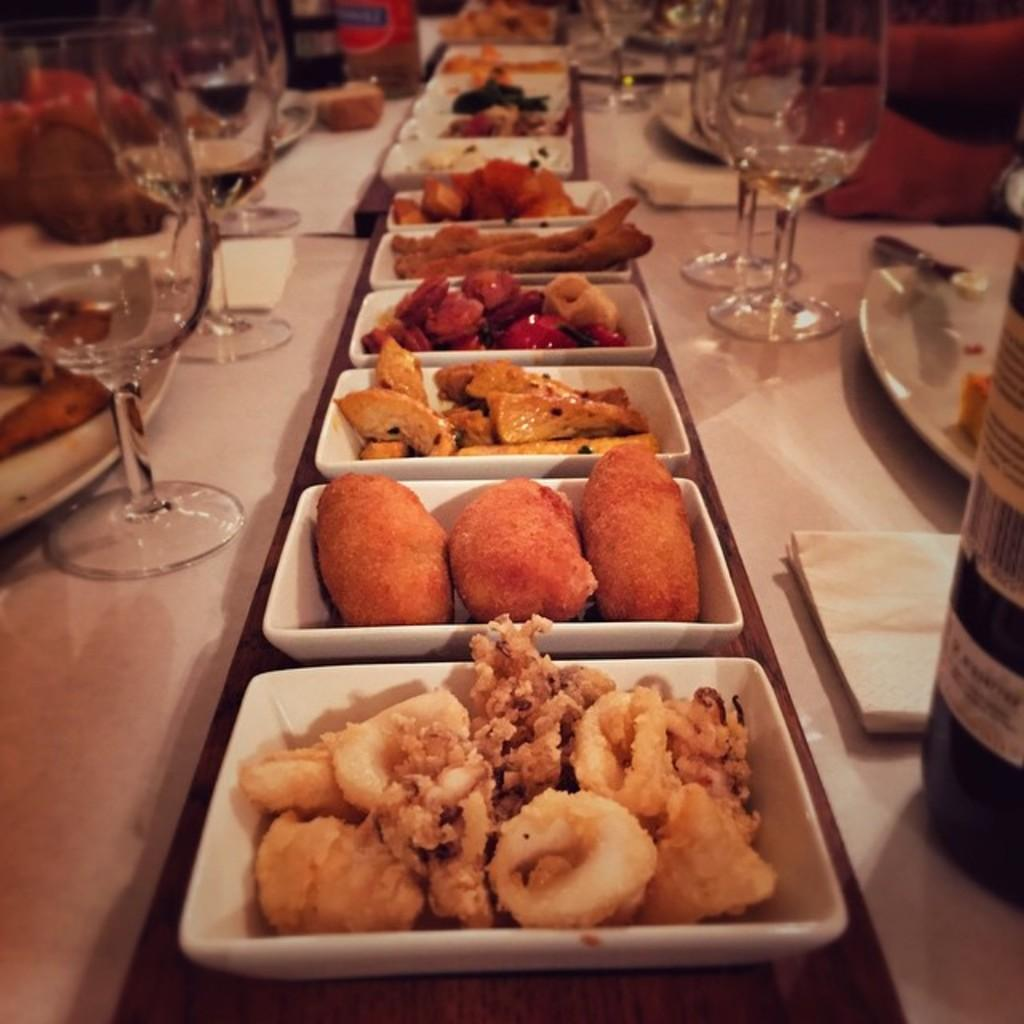What can be seen in the image in terms of food items? There are different types of food items in the image. Where are the food items placed? The food items are kept on a table. What is used to serve the food items? There are plates around the food items. What is used for drinking in the image? There are glasses around the food items. What is used for pouring liquids in the image? There are bottles around the food items. What arithmetic problem can be solved using the food items in the image? There is no arithmetic problem present in the image, as it features food items, plates, glasses, and bottles. What plot is being developed in the image? There is no plot being developed in the image, as it is a still image of food items and related items on a table. 